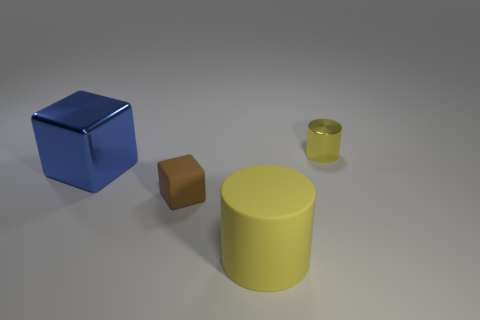Subtract all blue blocks. How many blocks are left? 1 Subtract 2 cylinders. How many cylinders are left? 0 Add 3 tiny brown blocks. How many objects exist? 7 Subtract all gray cylinders. Subtract all green balls. How many cylinders are left? 2 Subtract all tiny blue metallic balls. Subtract all metal cylinders. How many objects are left? 3 Add 2 blue metallic objects. How many blue metallic objects are left? 3 Add 4 large green blocks. How many large green blocks exist? 4 Subtract 0 gray cylinders. How many objects are left? 4 